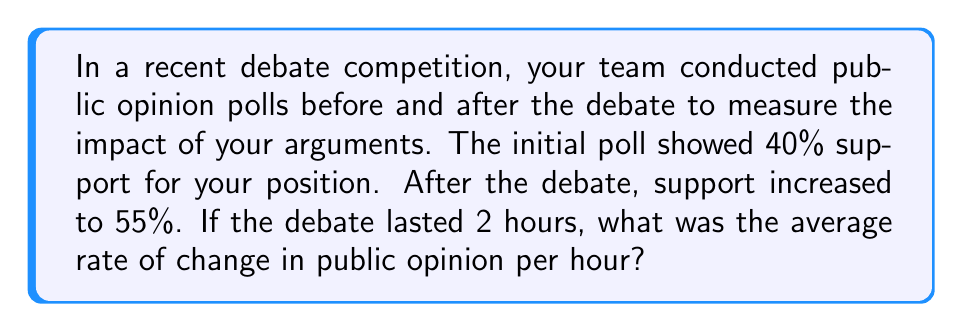Solve this math problem. To solve this problem, we need to follow these steps:

1. Calculate the total change in public opinion:
   Final support - Initial support = 55% - 40% = 15%

2. Determine the time interval:
   The debate lasted 2 hours

3. Use the rate of change formula:
   $$\text{Rate of change} = \frac{\text{Change in quantity}}{\text{Change in time}}$$

4. Plug in the values:
   $$\text{Rate of change} = \frac{15\%}{2 \text{ hours}}$$

5. Simplify:
   $$\text{Rate of change} = 7.5\% \text{ per hour}$$

This means that, on average, public opinion in favor of your position increased by 7.5% each hour during the debate.
Answer: $7.5\% \text{ per hour}$ 